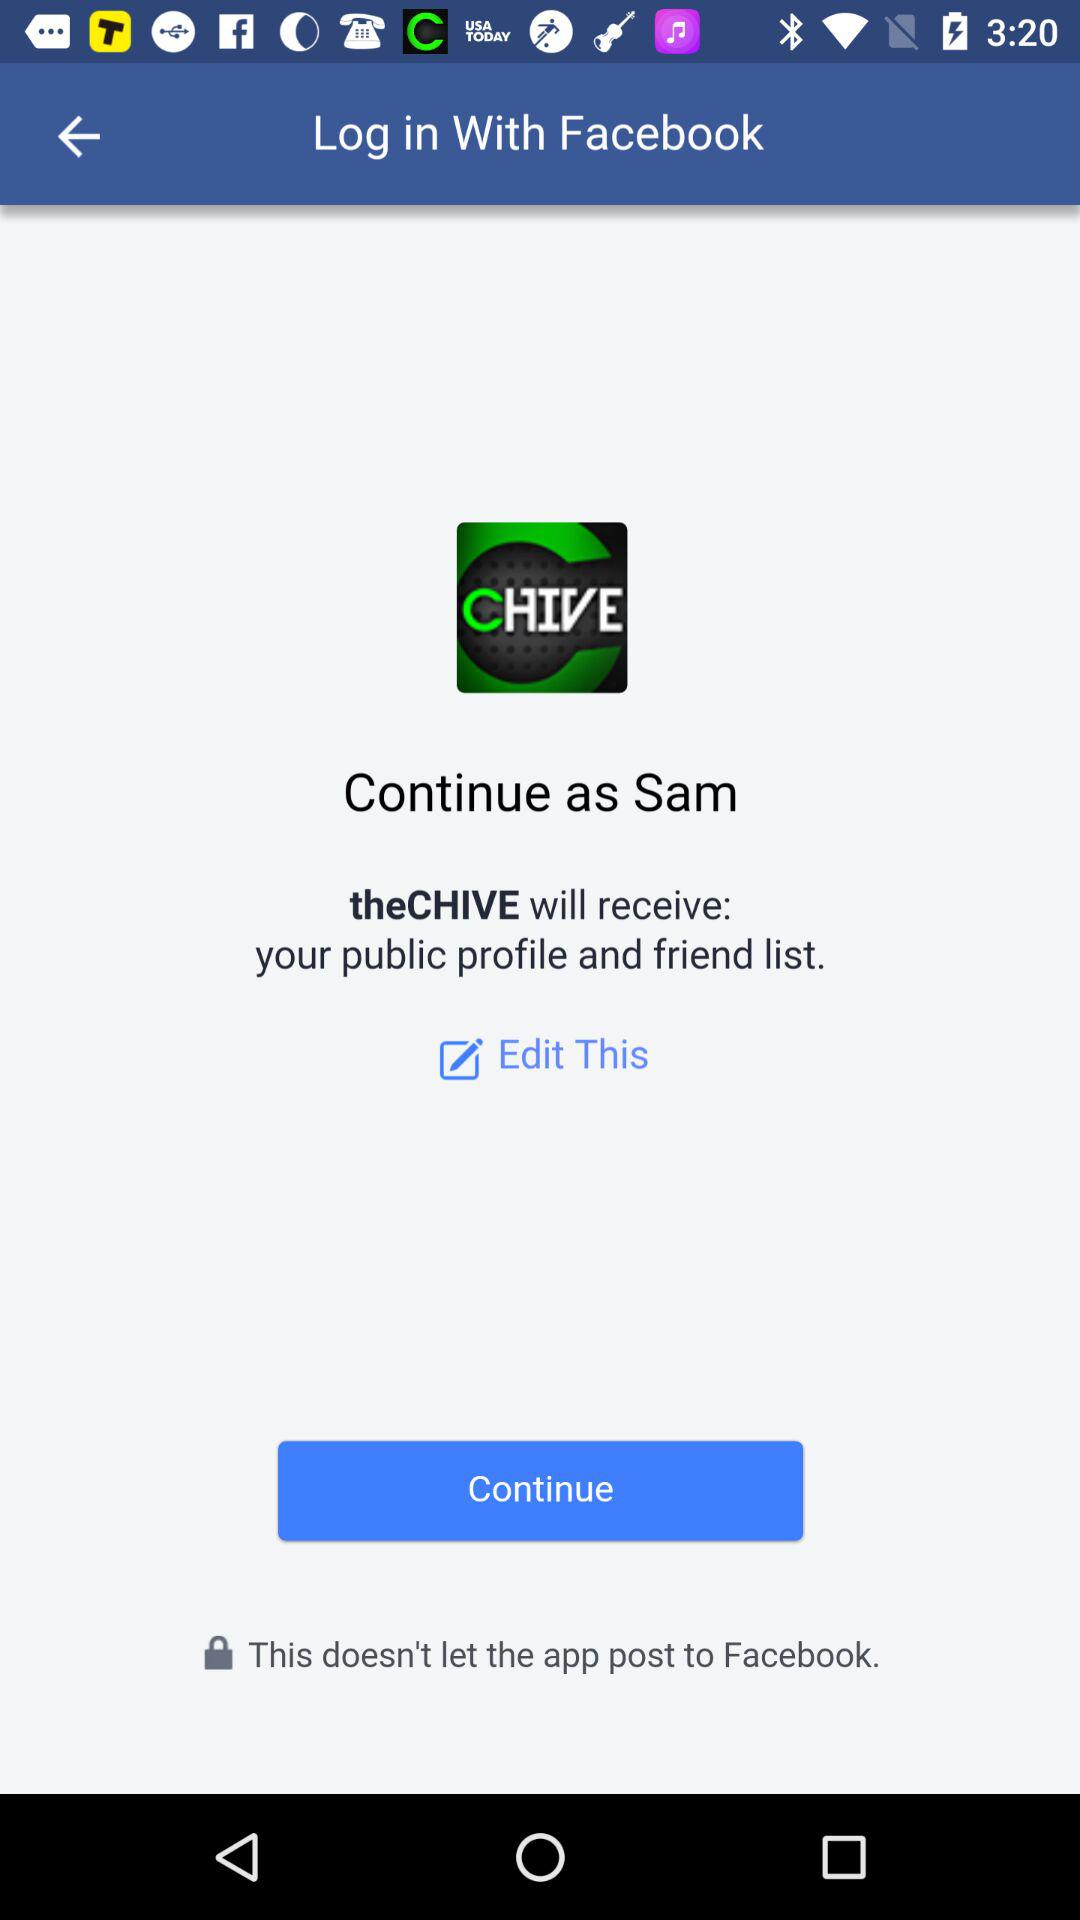What is the login name? The login name is Sam. 